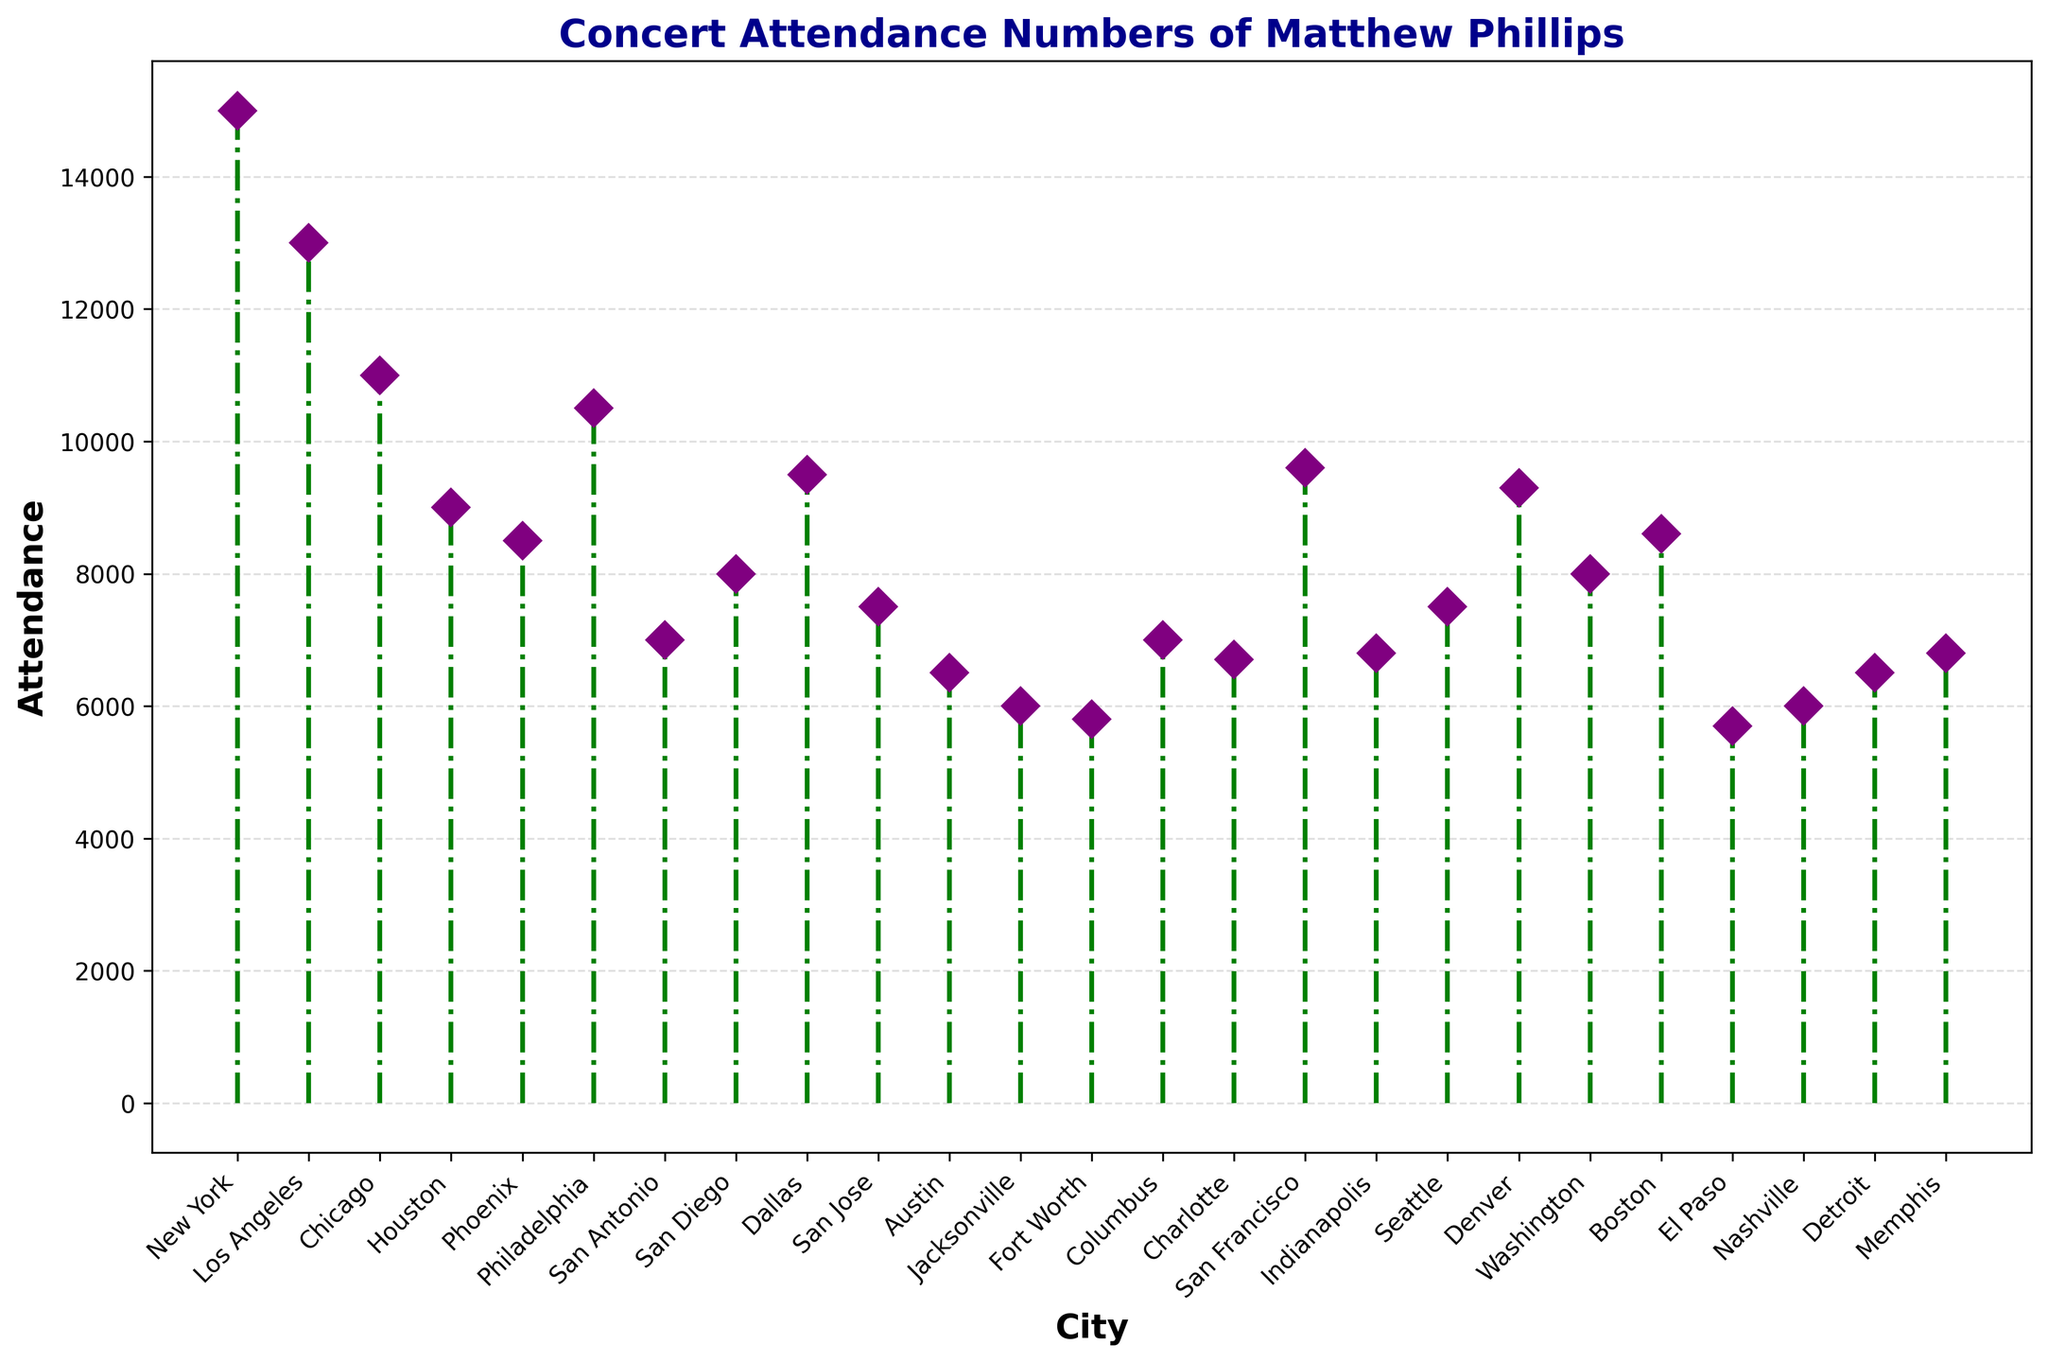What city had the highest concert attendance for Matthew Phillips? The highest marker in the stem plot represents the city with the highest attendance. This marker is located at New York with its point reaching 15,000.
Answer: New York Which city had a lower concert attendance, Seattle or San Jose? Comparing the heights of the markers for Seattle and San Jose, which are both set to 7,500, we see they are identical. However, the question asks for which had a lower attendance which implies a comparison, even though they are equal.
Answer: Seattle and San Jose had the same attendance What is the difference in concert attendance between Dallas and Houston? From the plot, we observe the attendance for Dallas is 9,500 and for Houston is 9,000. The difference is calculated as 9,500 - 9,000 = 500.
Answer: 500 How many cities had an attendance greater than 10,000? Observing the markers that exceed the 10,000 attendance line, we see New York, Los Angeles, and Philadelphia make up three cities exceeding 10,000 attendees.
Answer: 3 Which city had the lowest concert attendance, and what was the value? The lowest point in the plot is the city with the smallest attendance. This is El Paso with its marker at 5,700.
Answer: El Paso, 5,700 What is the total attendance for New York, Los Angeles, and Chicago? Adding the attendance values of New York (15,000), Los Angeles (13,000), and Chicago (11,000), we get 15,000 + 13,000 + 11,000 = 39,000.
Answer: 39,000 Is the attendance in Boston higher or lower than in Phoenix? From the plot, the marker for Boston shows an attendance of 8,600, while Phoenix shows 8,500. Therefore, Boston has a higher attendance.
Answer: Higher What is the average concert attendance across all recorded cities? Summing the attendance values and dividing by the total number of cities (25), we first calculate the sum (15,000 + 13,000 + 11,000 + 9,000 + 8,500 + 10,500 + 7,000 + 8,000 + 9,500 + 7,500 + 6,500 + 6,000 + 5,800 + 7,000 + 6,700 + 9,600 + 6,800 + 7,500 + 9,300 + 8,000 + 8,600 + 5,700 + 6,000 + 6,500 + 6,800 = 209,000). Then, the average is 209,000 / 25 = 8,360.
Answer: 8,360 What two cities have the nearest attendance values? From observation, Charlotte at 6,700 and Indianapolis at 6,800 have very close attendance values, a difference of only 100.
Answer: Charlotte and Indianapolis Which city had an attendance that was below average but closest to the average value? The average attendance is 8,360. Observing the markers below this value, among them Houston (9,000), Phoenix (8,500), Dallas (9,500) etc., Houston at 9,000 is just below but the closest to 8,360.
Answer: Houston 